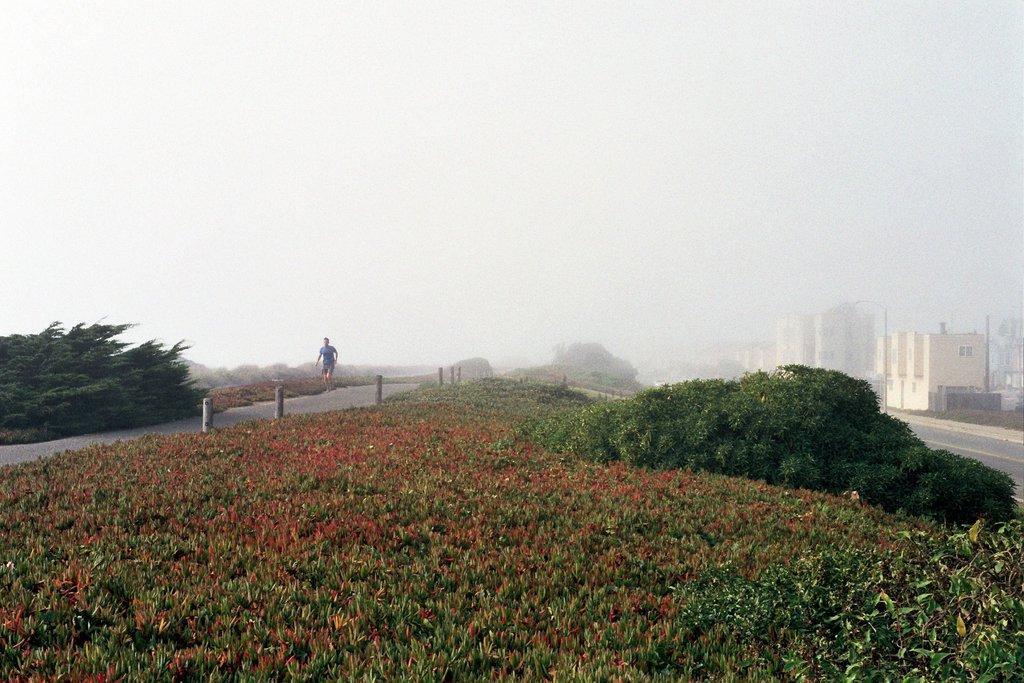Please provide a concise description of this image. In this picture I can see a man standing, there are plants, trees, there are houses, and in the background there is sky. 